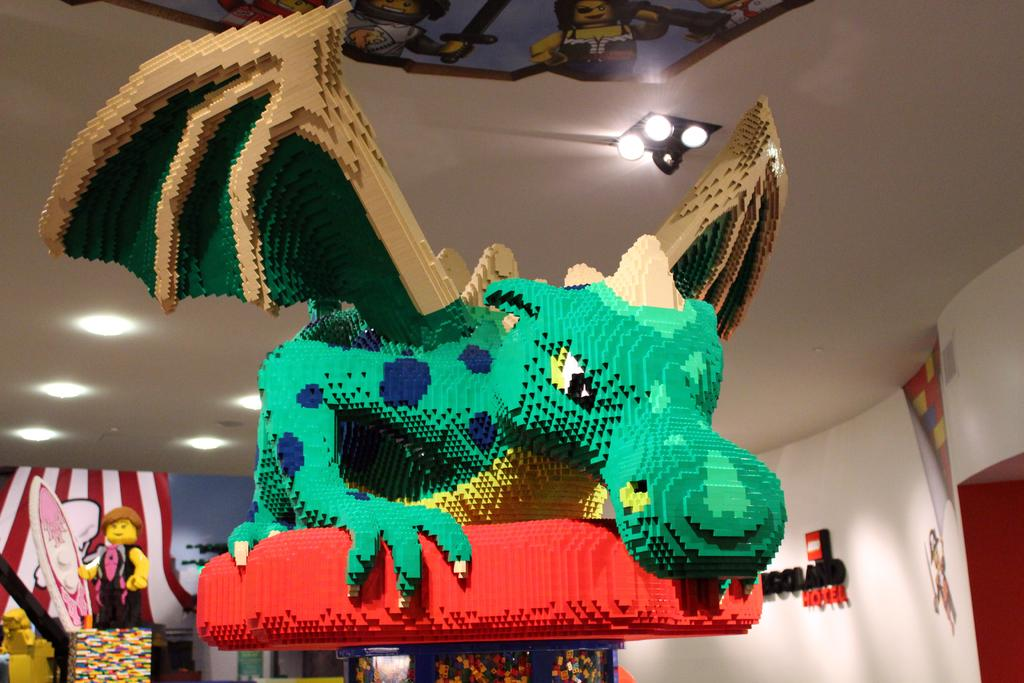What type of toy is in the image? There is a green dragon toy in the image. What is the dragon toy placed on? The dragon toy is on a red object. Can you describe any other objects visible in the image? There are other objects in the background of the image. What is attached to the roof in the image? There are lights attached to the roof in the image. What type of shoe is the dragon wearing in the image? The dragon toy is not wearing a shoe, as it is a toy and not a living creature. 